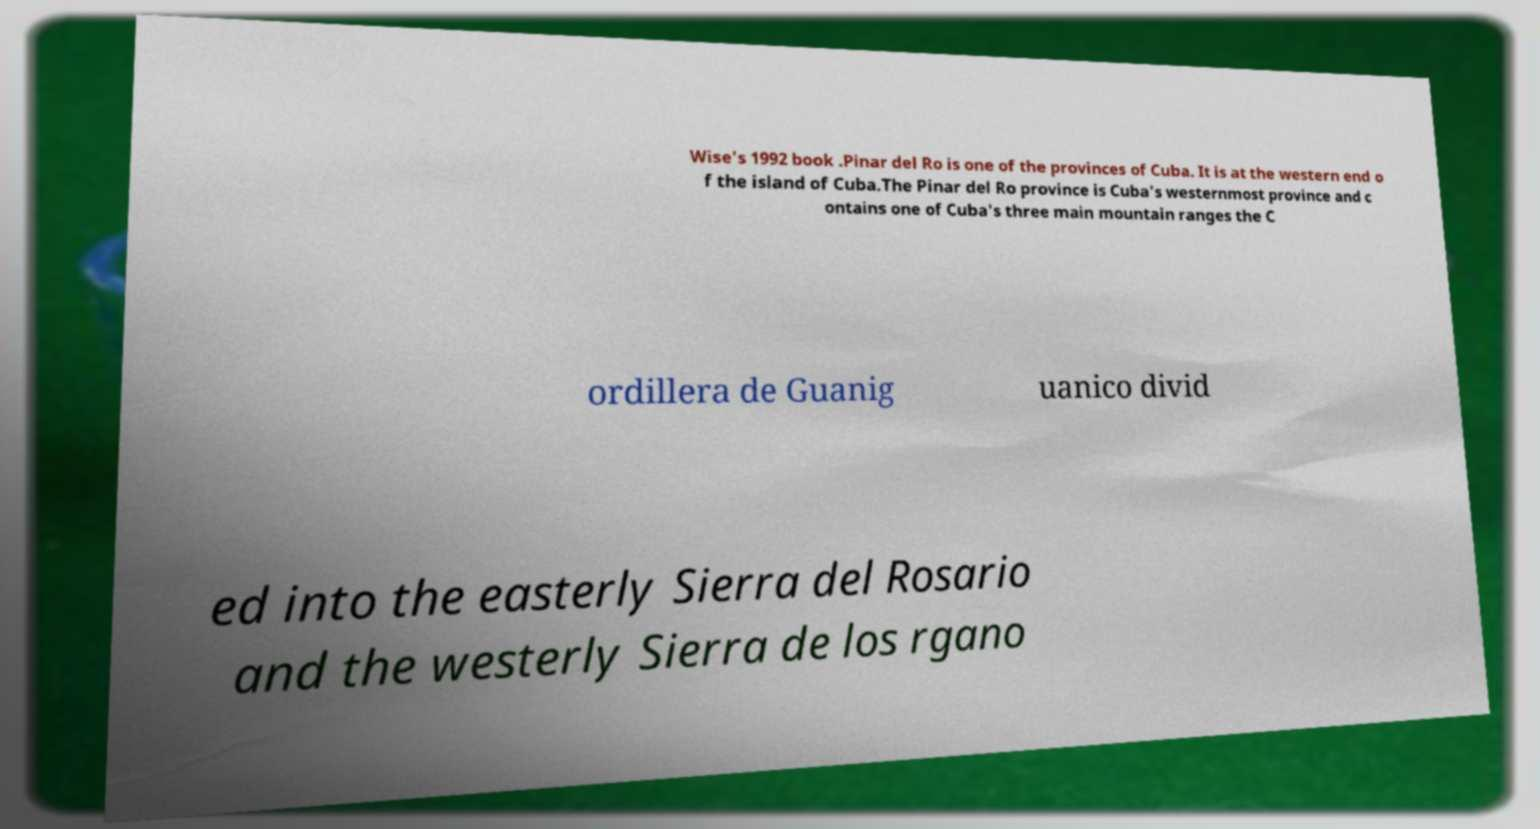Could you assist in decoding the text presented in this image and type it out clearly? Wise's 1992 book .Pinar del Ro is one of the provinces of Cuba. It is at the western end o f the island of Cuba.The Pinar del Ro province is Cuba's westernmost province and c ontains one of Cuba's three main mountain ranges the C ordillera de Guanig uanico divid ed into the easterly Sierra del Rosario and the westerly Sierra de los rgano 